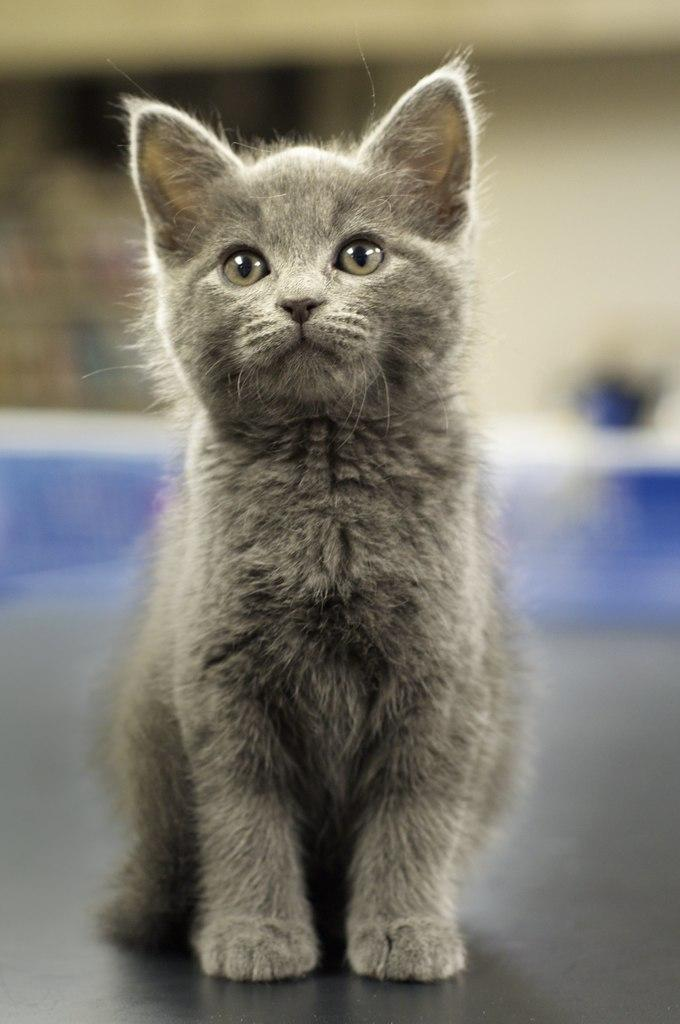What is the main subject of the image? There is a cat in the center of the image. What can be seen in the background of the image? There is a wall visible in the image. What type of polish is the cat using in the image? There is no polish present in the image, and the cat is not using any polish. Can you tell me how many zebras are visible in the image? There are no zebras present in the image. 